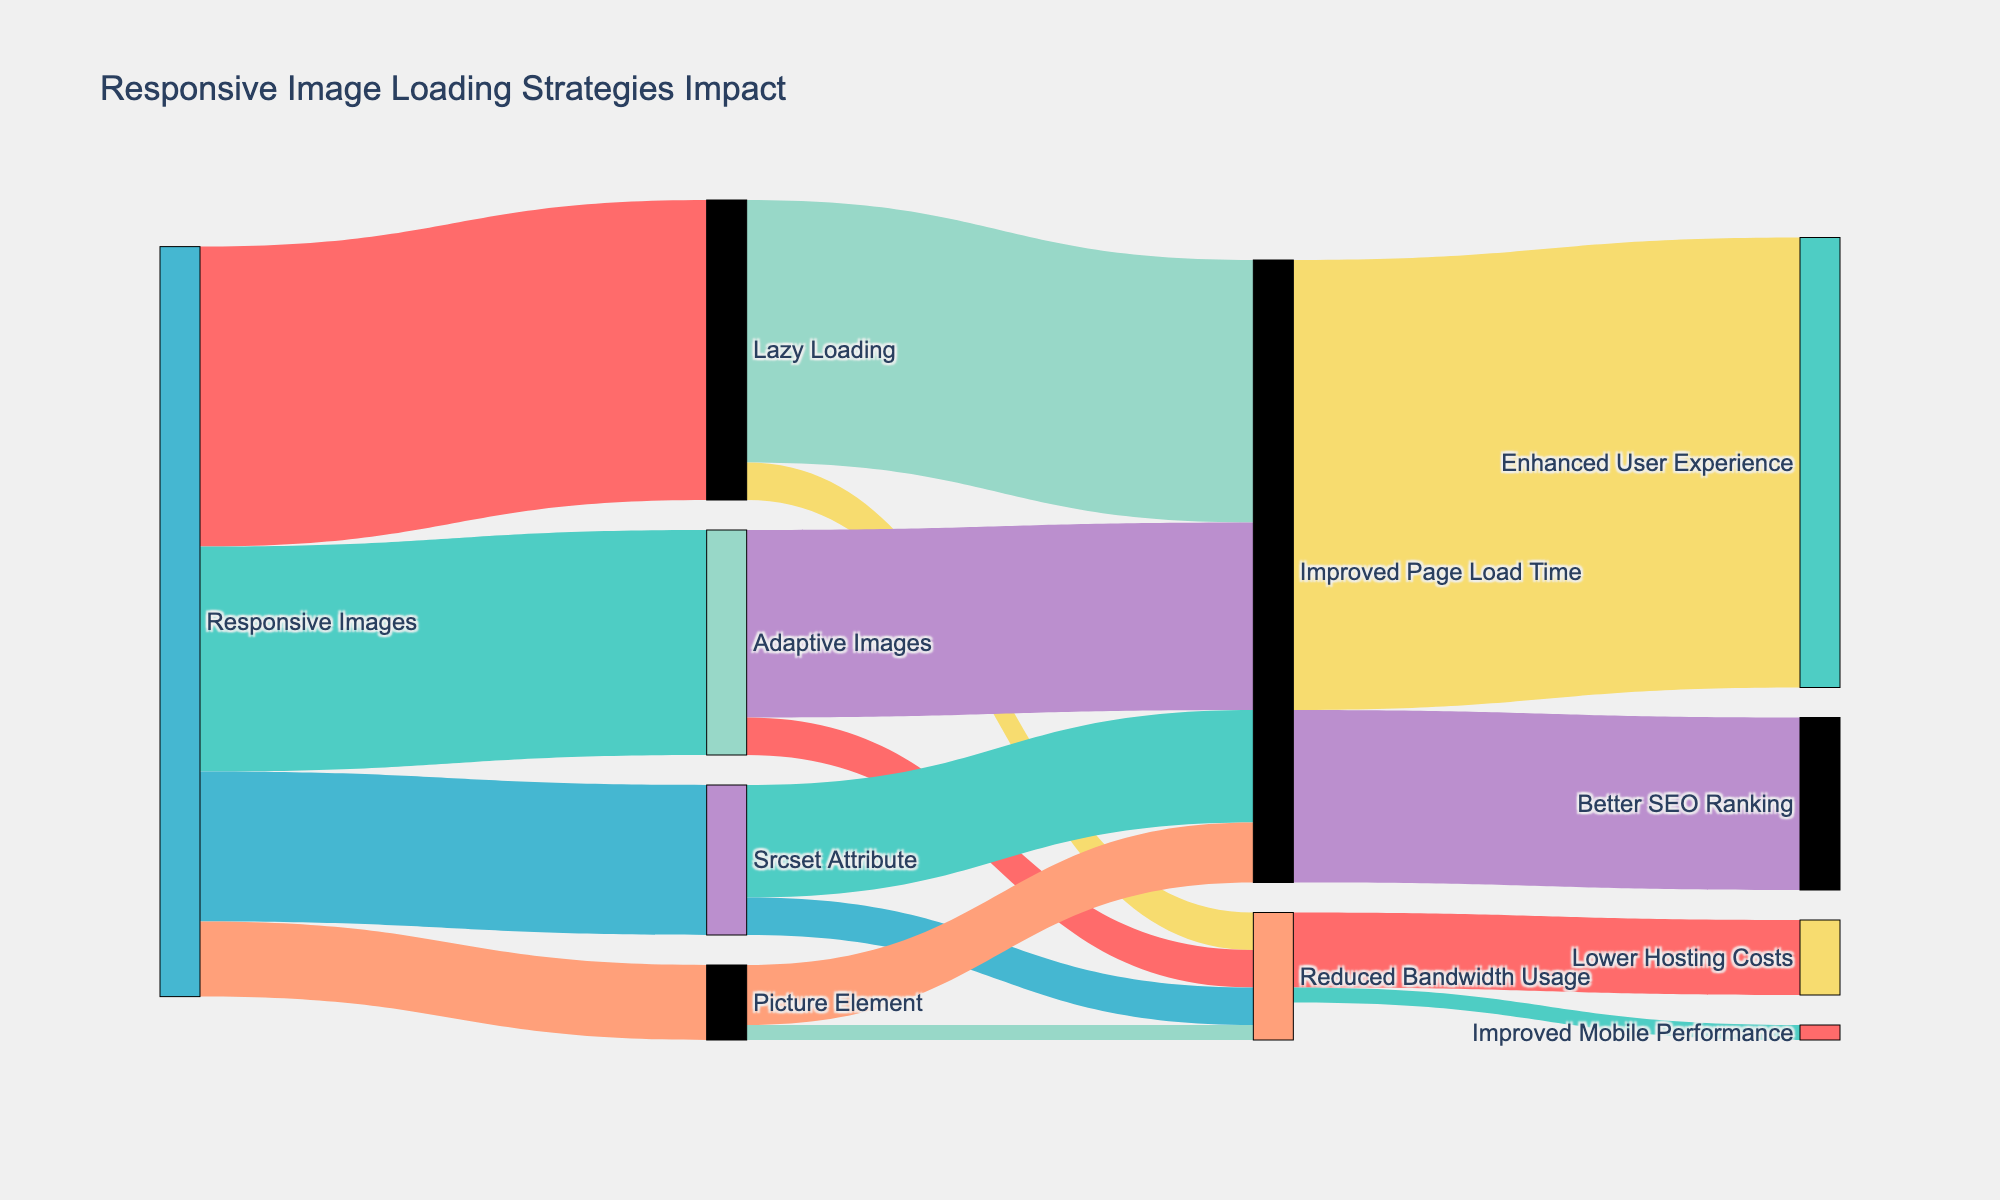What is the title of the figure? The title is usually displayed at the top of the figure. For this Sankey Diagram, the title given in the code is "Responsive Image Loading Strategies Impact."
Answer: "Responsive Image Loading Strategies Impact" Which responsive image loading strategy has the highest value directed towards "Improved Page Load Time"? To find this, look for the strategy with the highest numeric value directed to the "Improved Page Load Time" node. Lazy Loading has a value of 35, Adaptive Images has 25, Srcset Attribute has 15, and Picture Element has 8.
Answer: Lazy Loading How much total value contributes to "Improved Page Load Time" from all sources? Sum the values that lead to the "Improved Page Load Time" node: Lazy Loading (35) + Adaptive Images (25) + Srcset Attribute (15) + Picture Element (8). 35 + 25 + 15 + 8 = 83
Answer: 83 What is the total value flowing from "Responsive Images" to all its targets? To get the answer, sum the values of all links originating from "Responsive Images": Lazy Loading (40) + Adaptive Images (30) + Srcset Attribute (20) + Picture Element (10). 40 + 30 + 20 + 10 = 100
Answer: 100 Which strategy affects "Improved Page Load Time" and "Reduced Bandwidth Usage" almost evenly in value? Check the values for each strategy directed towards both "Improved Page Load Time" and "Reduced Bandwidth Usage." Lazy Loading has a disproportionate value (35 vs. 5), Adaptive Images (25 vs. 5), Srcset Attribute is more balanced with (15 vs. 5).
Answer: Srcset Attribute What is the sum of values contributing to "Enhanced User Experience" from "Improved Page Load Time"? Only the value directly from "Improved Page Load Time" to "Enhanced User Experience" is considered, which is 60.
Answer: 60 Which node has the lowest total incoming value? Calculate the sum of incoming values for each node. "Adaptive Images" and "Picture Element" send 2 to "Improved Mobile Performance," which is less than any other node’s incoming sums.
Answer: Improved Mobile Performance How does the total value directed to "Reduced Bandwidth Usage" compare with that directed to "Improved Page Load Time"? Sum the values directed to each: Reduced Bandwidth Usage (5+5+5+2 = 17) and Improved Page Load Time (35+25+15+8 = 83). 83 is significantly higher than 17.
Answer: Improved Page Load Time has a higher value Which strategy shares the smallest portion of the total value allocated from "Responsive Images"? Compare values of Lazy Loading (40), Adaptive Images (30), Srcset Attribute (20), and Picture Element (10). The smallest value is from Picture Element (10).
Answer: Picture Element 